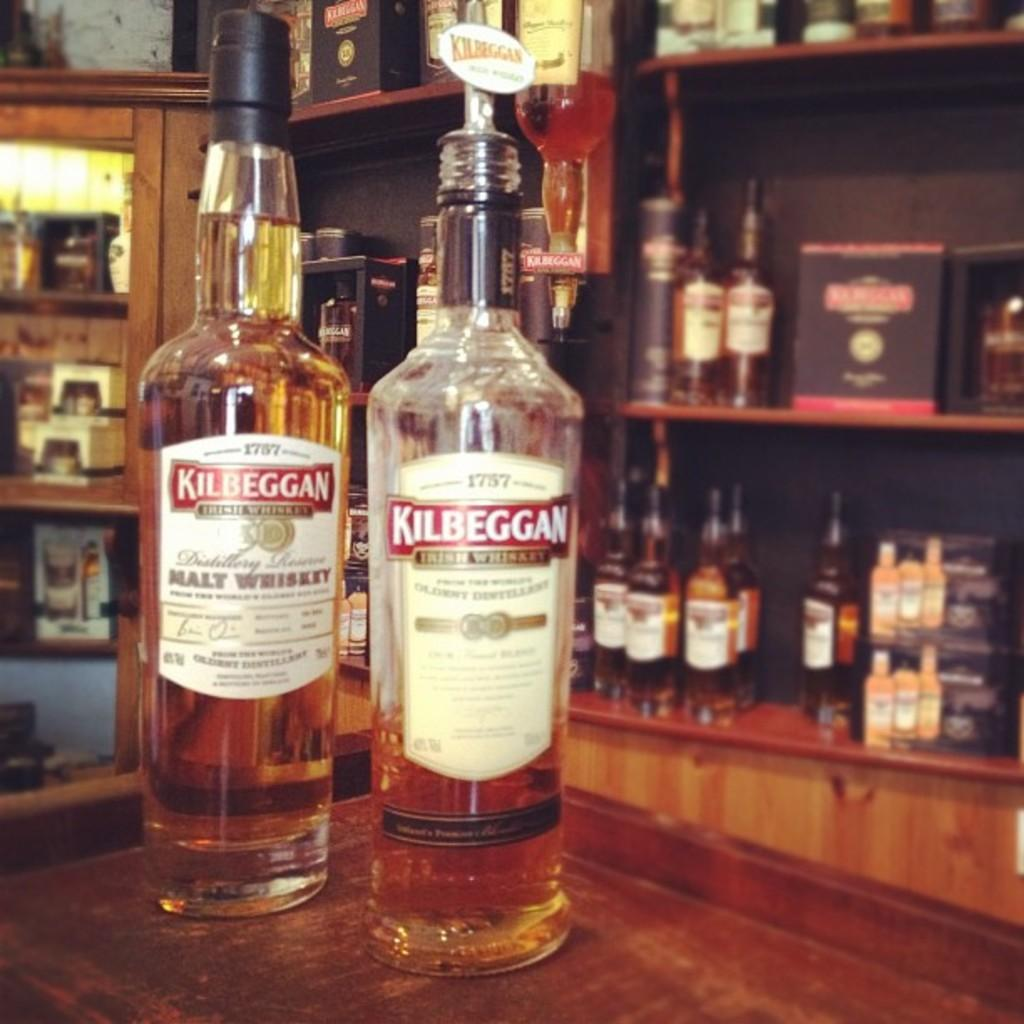<image>
Write a terse but informative summary of the picture. Bottle with a label that says Kilbeggan on it. 